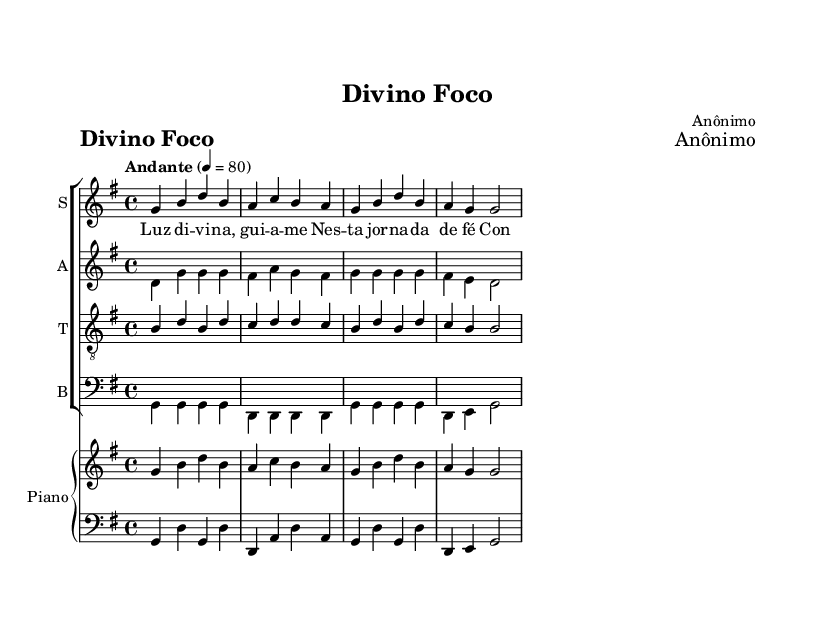What is the key signature of this music? The key signature is G major, which has one sharp (F#). This can be identified by looking at the key signature at the beginning of the staff.
Answer: G major What is the time signature of this piece? The time signature is 4/4, indicated at the beginning of the score. This means there are four beats in each measure and the quarter note gets one beat.
Answer: 4/4 What is the tempo marking of this composition? The tempo is marked "Andante," which indicates a moderately slow pace. This can be seen above the staff at the beginning of the piece.
Answer: Andante How many voices are included in the choral arrangement? There are four voices in the choral arrangement: soprano, alto, tenor, and bass. This can be determined by the different staves labeled for each voice type.
Answer: Four What is the title of this piece? The title of the piece is "Divino Foco," as indicated in the header section at the top of the sheet music.
Answer: Divino Foco What type of music is this sheet music representing? This is a piece of religious choral music designed for concentration and productivity, as described in the question context.
Answer: Religious choral music What lyrical theme is present in the verses? The lyrical theme revolves around light, guidance, and finding concentration and peace in faith. This can be inferred from the words included in the lyric section.
Answer: Faith and peace 